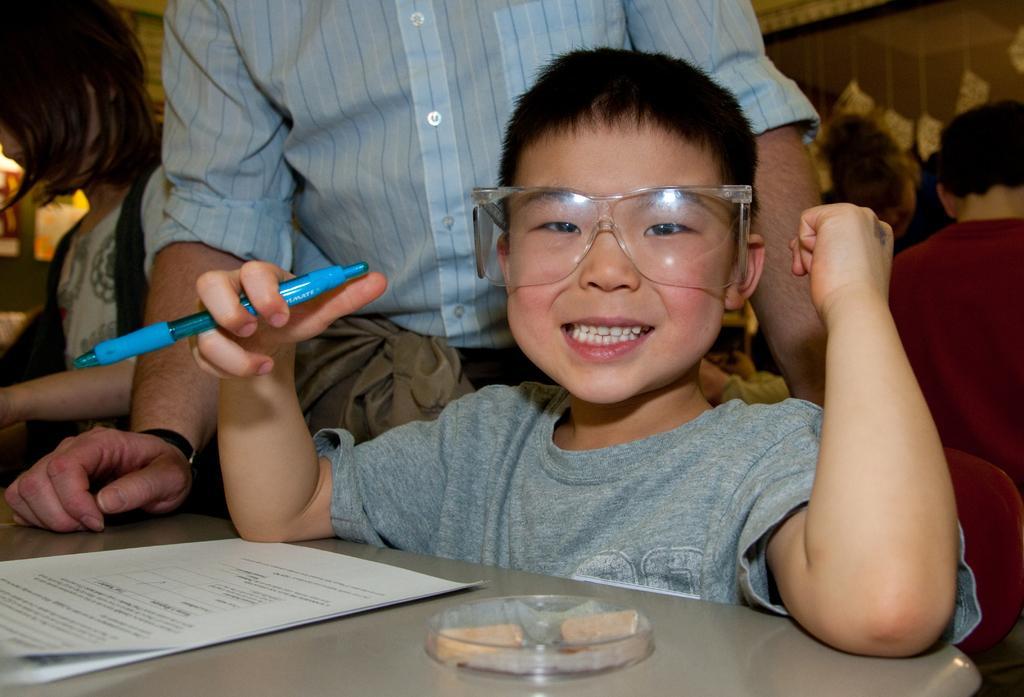How would you summarize this image in a sentence or two? In this image in the foreground there is one boy who is holding a pen, in front of the boy there is one table. On the table there are some papers and some object, in the background there are a group of people, wall, and some other objects. 